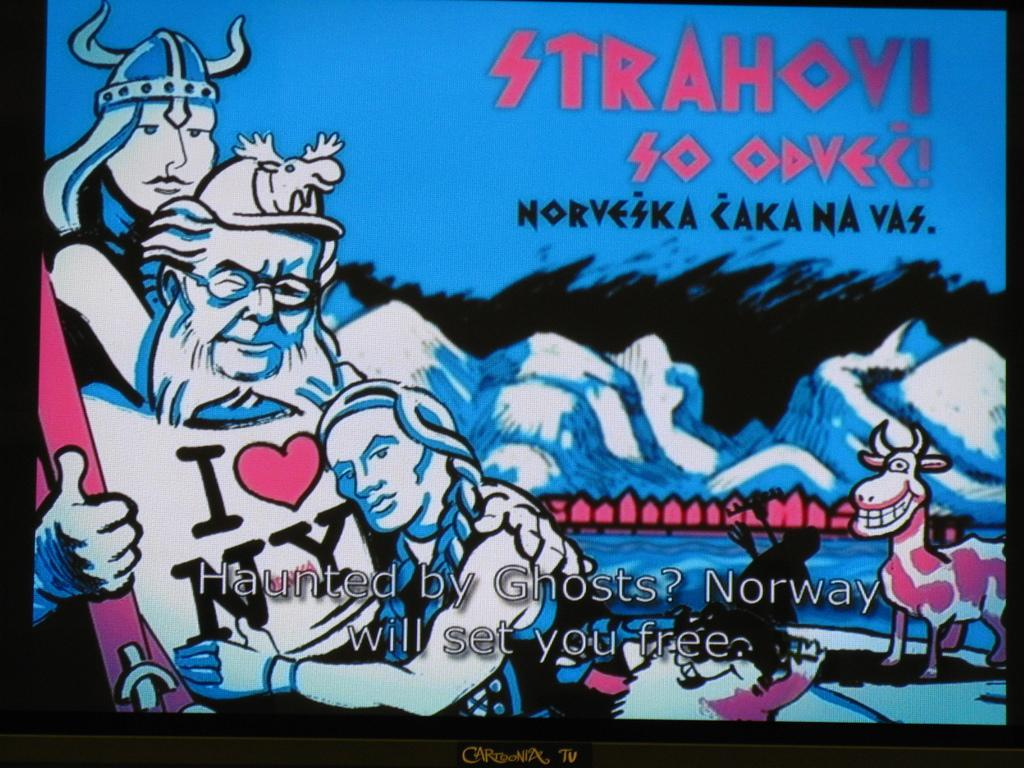<image>
Share a concise interpretation of the image provided. an artistic image of a woman hugging a man with an i heart new york shirt. 